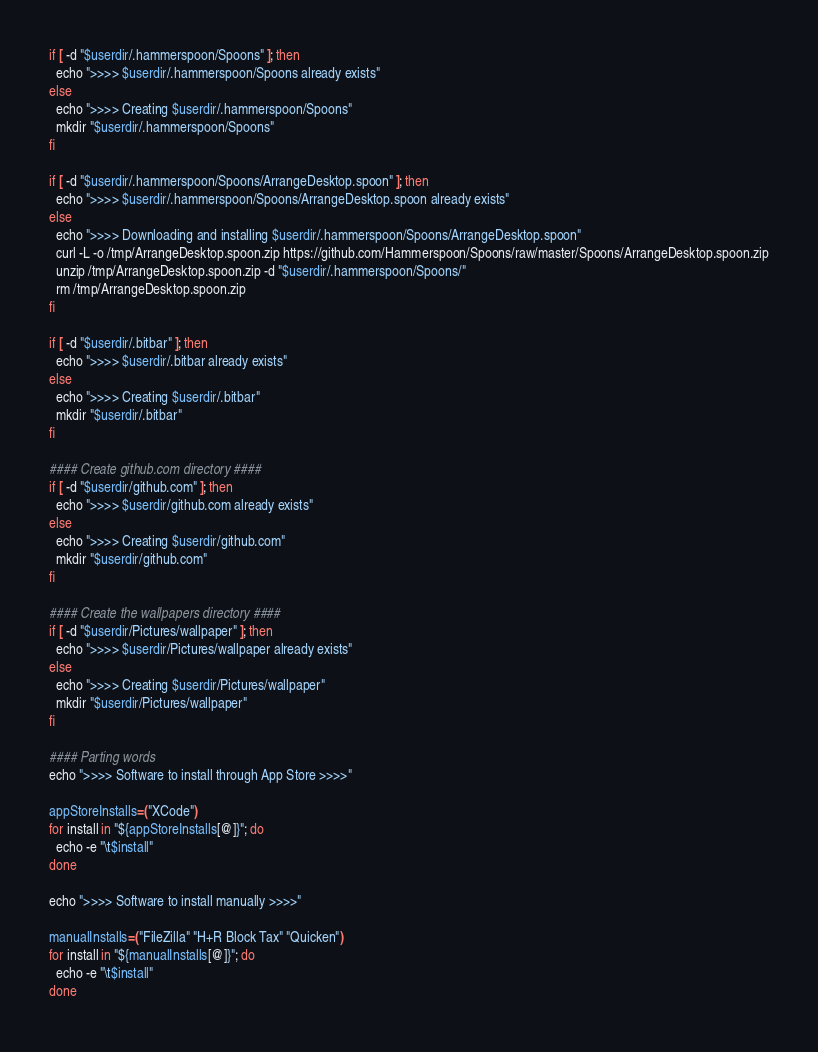Convert code to text. <code><loc_0><loc_0><loc_500><loc_500><_Bash_>
if [ -d "$userdir/.hammerspoon/Spoons" ]; then
  echo ">>>> $userdir/.hammerspoon/Spoons already exists"
else
  echo ">>>> Creating $userdir/.hammerspoon/Spoons"
  mkdir "$userdir/.hammerspoon/Spoons"
fi

if [ -d "$userdir/.hammerspoon/Spoons/ArrangeDesktop.spoon" ]; then
  echo ">>>> $userdir/.hammerspoon/Spoons/ArrangeDesktop.spoon already exists"
else
  echo ">>>> Downloading and installing $userdir/.hammerspoon/Spoons/ArrangeDesktop.spoon"
  curl -L -o /tmp/ArrangeDesktop.spoon.zip https://github.com/Hammerspoon/Spoons/raw/master/Spoons/ArrangeDesktop.spoon.zip
  unzip /tmp/ArrangeDesktop.spoon.zip -d "$userdir/.hammerspoon/Spoons/"
  rm /tmp/ArrangeDesktop.spoon.zip
fi

if [ -d "$userdir/.bitbar" ]; then
  echo ">>>> $userdir/.bitbar already exists"
else
  echo ">>>> Creating $userdir/.bitbar"
  mkdir "$userdir/.bitbar"
fi

#### Create github.com directory ####
if [ -d "$userdir/github.com" ]; then
  echo ">>>> $userdir/github.com already exists"
else
  echo ">>>> Creating $userdir/github.com"
  mkdir "$userdir/github.com"
fi

#### Create the wallpapers directory ####
if [ -d "$userdir/Pictures/wallpaper" ]; then
  echo ">>>> $userdir/Pictures/wallpaper already exists"
else
  echo ">>>> Creating $userdir/Pictures/wallpaper"
  mkdir "$userdir/Pictures/wallpaper"
fi

#### Parting words
echo ">>>> Software to install through App Store >>>>"

appStoreInstalls=("XCode")
for install in "${appStoreInstalls[@]}"; do
  echo -e "\t$install"
done

echo ">>>> Software to install manually >>>>"

manualInstalls=("FileZilla" "H+R Block Tax" "Quicken")
for install in "${manualInstalls[@]}"; do
  echo -e "\t$install"
done
</code> 